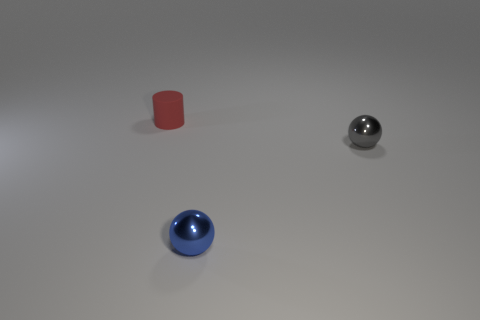Add 2 tiny rubber things. How many objects exist? 5 Subtract all cylinders. How many objects are left? 2 Subtract 0 gray cylinders. How many objects are left? 3 Subtract all spheres. Subtract all tiny red cylinders. How many objects are left? 0 Add 1 gray metal spheres. How many gray metal spheres are left? 2 Add 2 red matte things. How many red matte things exist? 3 